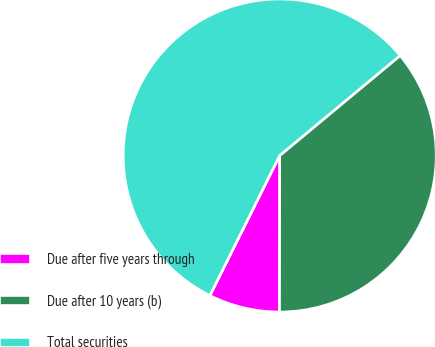<chart> <loc_0><loc_0><loc_500><loc_500><pie_chart><fcel>Due after five years through<fcel>Due after 10 years (b)<fcel>Total securities<nl><fcel>7.34%<fcel>36.05%<fcel>56.61%<nl></chart> 